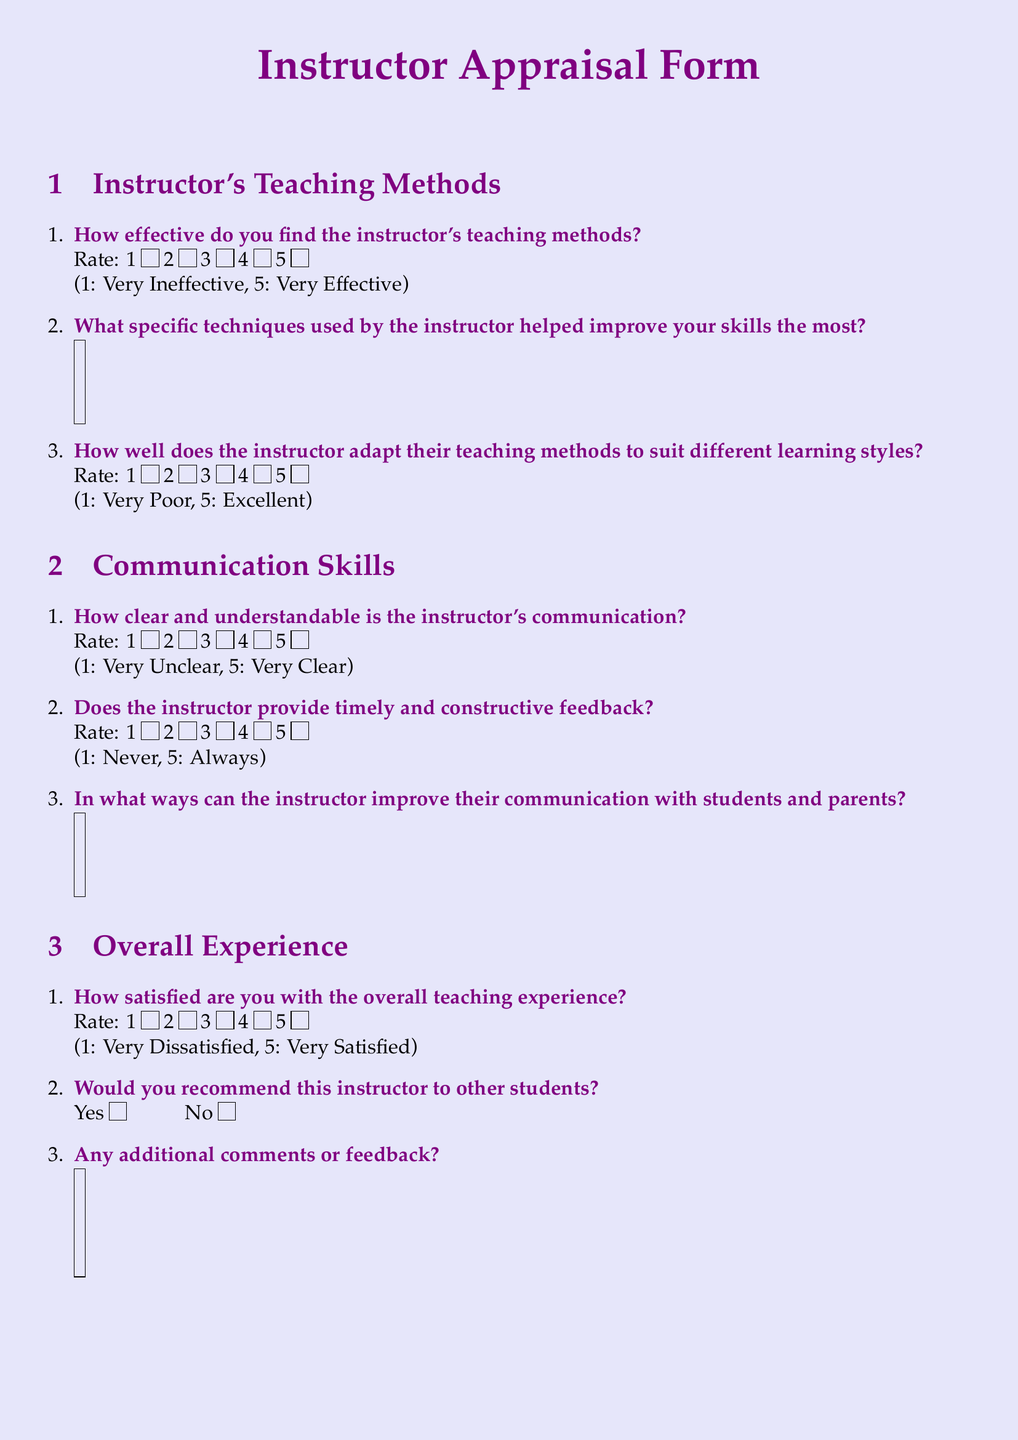What is the main title of the document? The title is highlighted in a large font at the top of the document, indicating the purpose of the appraisal form.
Answer: Instructor Appraisal Form How many sections are in the form? The form is divided into three clear sections, each with its own focus related to the instructor's performance.
Answer: 3 What is the highest rating score available for teaching effectiveness? The rating scale is defined clearly, indicating the maximum score that can be given for effectiveness in teaching.
Answer: 5 What is the first question regarding communication skills? The first question in the communication skills section asks about the clarity of the instructor’s communication.
Answer: How clear and understandable is the instructor's communication? What rating is used to evaluate the overall teaching experience? The document outlines a specific rating scale used to assess satisfaction regarding the overall experience with the instructor.
Answer: 1 to 5 What type of feedback does the instructor provide according to the form? The appraisal form seeks to assess whether the instructor gives feedback in a specific manner regarding its timing and constructiveness.
Answer: Timely and constructive feedback How does the form suggest students indicate their recommendation of the instructor? The form includes a simple yes/no option for students to express their recommendation for the instructor.
Answer: Yes or No What is an open-ended question included in the form? The document features space for respondents to provide qualitative insights or feedback, indicative of a desire for detailed responses.
Answer: Any additional comments or feedback? 